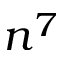Convert formula to latex. <formula><loc_0><loc_0><loc_500><loc_500>n ^ { 7 }</formula> 